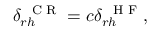<formula> <loc_0><loc_0><loc_500><loc_500>\delta _ { r h } ^ { C R } = c \delta _ { r h } ^ { H F } ,</formula> 